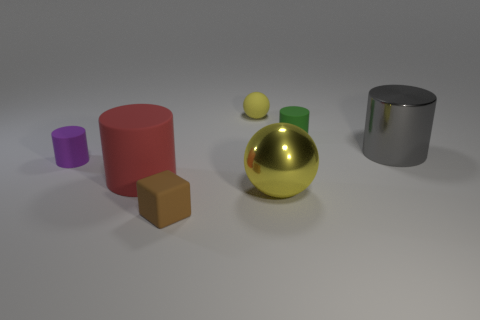Subtract 2 cylinders. How many cylinders are left? 2 Subtract all matte cylinders. How many cylinders are left? 1 Subtract all green cylinders. How many cylinders are left? 3 Add 3 brown matte things. How many objects exist? 10 Subtract all brown cylinders. Subtract all green blocks. How many cylinders are left? 4 Subtract all cylinders. How many objects are left? 3 Subtract 0 green spheres. How many objects are left? 7 Subtract all tiny yellow rubber objects. Subtract all big yellow metal things. How many objects are left? 5 Add 1 purple matte cylinders. How many purple matte cylinders are left? 2 Add 7 small purple things. How many small purple things exist? 8 